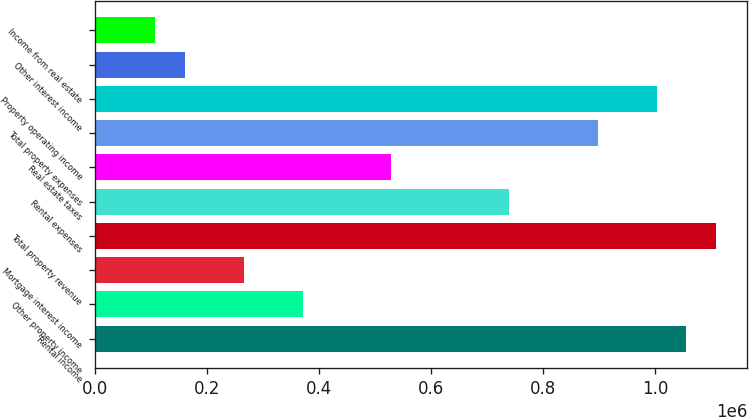<chart> <loc_0><loc_0><loc_500><loc_500><bar_chart><fcel>Rental income<fcel>Other property income<fcel>Mortgage interest income<fcel>Total property revenue<fcel>Rental expenses<fcel>Real estate taxes<fcel>Total property expenses<fcel>Property operating income<fcel>Other interest income<fcel>Income from real estate<nl><fcel>1.05589e+06<fcel>370373<fcel>264909<fcel>1.10862e+06<fcel>739497<fcel>528569<fcel>897693<fcel>1.00316e+06<fcel>159445<fcel>106713<nl></chart> 